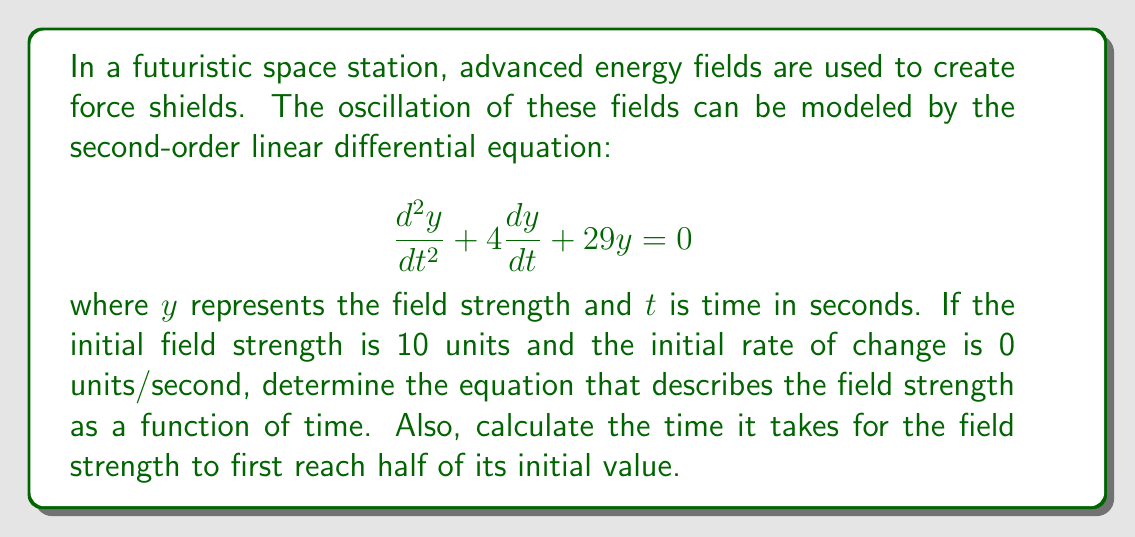Help me with this question. To solve this problem, we'll follow these steps:

1) The characteristic equation for this differential equation is:
   $$r^2 + 4r + 29 = 0$$

2) Solving this quadratic equation:
   $$r = \frac{-4 \pm \sqrt{4^2 - 4(1)(29)}}{2(1)} = \frac{-4 \pm \sqrt{16 - 116}}{2} = \frac{-4 \pm \sqrt{-100}}{2} = -2 \pm 5i$$

3) The general solution is therefore:
   $$y(t) = e^{-2t}(A\cos(5t) + B\sin(5t))$$

4) Using the initial conditions:
   At $t=0$, $y(0) = 10$ and $y'(0) = 0$

5) Applying the first condition:
   $$10 = A$$

6) For the second condition, we differentiate $y(t)$:
   $$y'(t) = e^{-2t}(-2A\cos(5t) - 2B\sin(5t) - 5A\sin(5t) + 5B\cos(5t))$$
   
   At $t=0$:
   $$0 = -2A + 5B$$
   $$0 = -2(10) + 5B$$
   $$B = 4$$

7) Therefore, the solution is:
   $$y(t) = e^{-2t}(10\cos(5t) + 4\sin(5t))$$

8) To find when the field strength first reaches half its initial value:
   $$5 = e^{-2t}(10\cos(5t) + 4\sin(5t))$$
   
   This equation can't be solved algebraically. We need to use numerical methods or graphing to find the first positive t that satisfies this equation.

9) Using a numerical solver, we find that the first time this occurs is approximately at $t \approx 0.2306$ seconds.
Answer: The equation describing the field strength as a function of time is:
$$y(t) = e^{-2t}(10\cos(5t) + 4\sin(5t))$$

The time it takes for the field strength to first reach half of its initial value is approximately 0.2306 seconds. 